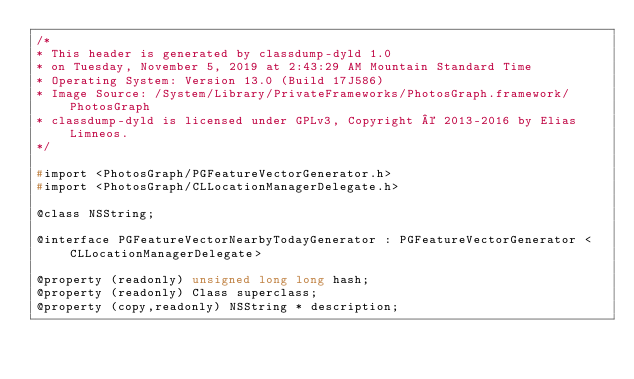<code> <loc_0><loc_0><loc_500><loc_500><_C_>/*
* This header is generated by classdump-dyld 1.0
* on Tuesday, November 5, 2019 at 2:43:29 AM Mountain Standard Time
* Operating System: Version 13.0 (Build 17J586)
* Image Source: /System/Library/PrivateFrameworks/PhotosGraph.framework/PhotosGraph
* classdump-dyld is licensed under GPLv3, Copyright © 2013-2016 by Elias Limneos.
*/

#import <PhotosGraph/PGFeatureVectorGenerator.h>
#import <PhotosGraph/CLLocationManagerDelegate.h>

@class NSString;

@interface PGFeatureVectorNearbyTodayGenerator : PGFeatureVectorGenerator <CLLocationManagerDelegate>

@property (readonly) unsigned long long hash; 
@property (readonly) Class superclass; 
@property (copy,readonly) NSString * description; </code> 